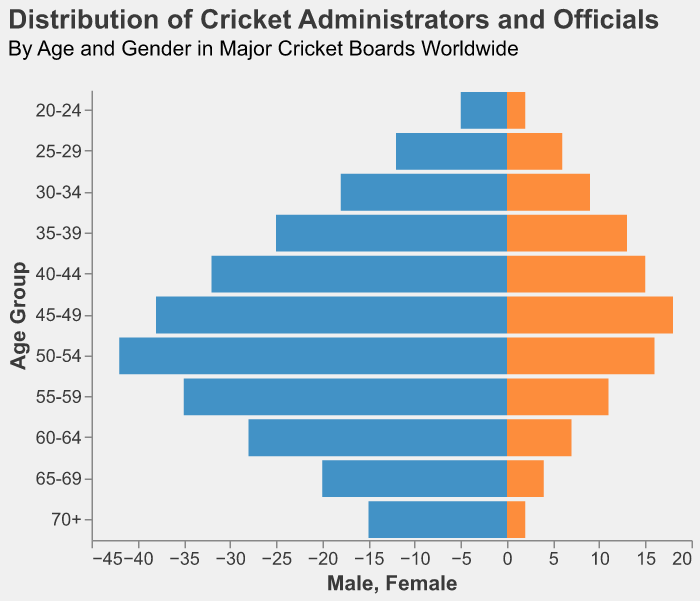What is the age group with the highest number of male cricket administrators and officials? Looking at the population pyramid, the age group with the longest bar on the male side (left side, colored in blue) is labeled 50-54. Therefore, the highest number of male cricket administrators and officials is in the age group 50-54.
Answer: 50-54 How many female cricket administrators and officials are in the age group 40-44? From the population pyramid, we can see the bar for females (right side, colored in orange) in the age group 40-44 ends at 15. Thus, there are 15 female cricket administrators and officials in this age group.
Answer: 15 What is the total number of cricket administrators and officials in the age group 25-29? Adding the values for males and females in this age group, we have 12 males and 6 females. Therefore, the total is 12 + 6 = 18.
Answer: 18 Which gender has more administrators and officials in the age group 65-69? For the age group 65-69, the length of the bar on the left side (male) is longer than the right side (female). Specifically, there are 20 males and 4 females. Therefore, males have more administrators and officials in this age group.
Answer: Males What is the average number of male cricket administrators and officials aged 45-64? We need to find the sum of male administrators in the age groups 45-49, 50-54, 55-59, and 60-64 and then divide by the number of age groups. So, the calculation is (38 + 42 + 35 + 28) / 4 = 143 / 4 = 35.75.
Answer: 35.75 How does the number of female cricket officials in the 70+ age group compare to the number of male officials in the same group? The population pyramid shows 2 females and 15 males in the 70+ age group. Comparing these values, there are significantly more males than females in the 70+ age group.
Answer: Males have more Which age group has the closest ratio of male to female cricket administrators and officials? Reviewing the bars on both sides, the age group 25-29 shows 12 males and 6 females, giving a ratio closest to 2:1. This is the most balanced among the displayed age groups.
Answer: 25-29 Which gender has a decreasing trend in the number of administrators and officials starting from the age group 45-49? Looking at the population pyramid, the male side shows a decreasing trend from 45-49 onwards whereas the female side does not consistently follow a decreasing trend.
Answer: Males What is the total number of male and female cricket administrators and officials in the age group 60-64? Adding the values for both genders in this age group, we have 28 males and 7 females. Therefore, the total is 28 + 7 = 35.
Answer: 35 Which age group has the largest disparity between the number of male and female cricket administrators and officials? The age group 50-54 shows the largest difference with 42 males and 16 females. The disparity is 42 - 16 = 26.
Answer: 50-54 